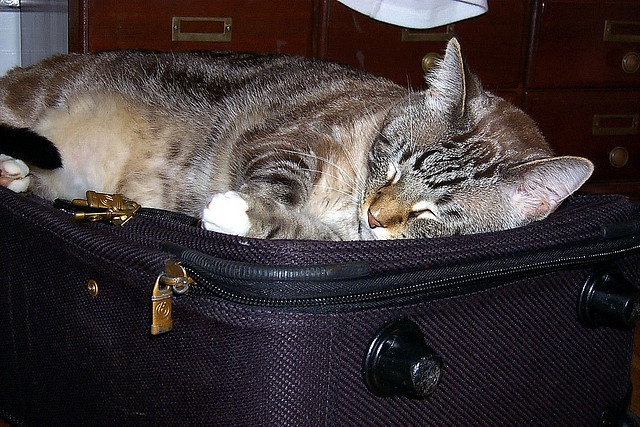Describe the objects in this image and their specific colors. I can see suitcase in purple, black, and gray tones and cat in purple, gray, darkgray, black, and lightgray tones in this image. 